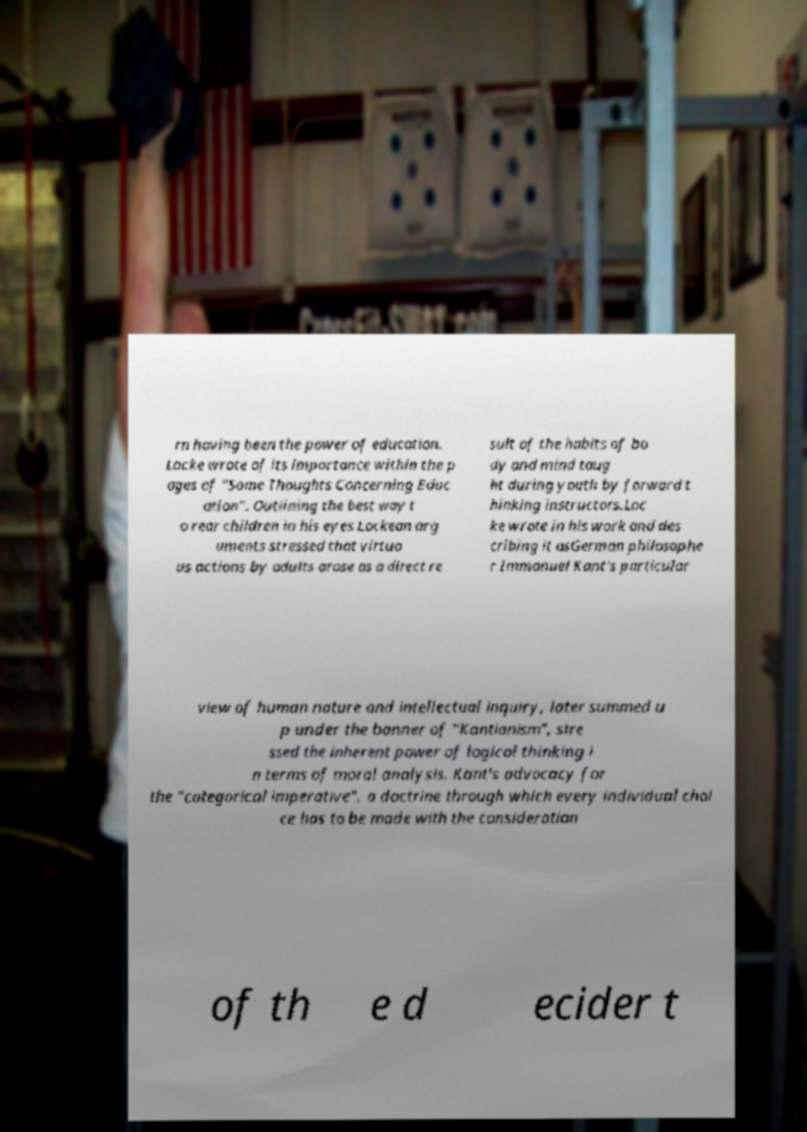For documentation purposes, I need the text within this image transcribed. Could you provide that? rn having been the power of education. Locke wrote of its importance within the p ages of "Some Thoughts Concerning Educ ation". Outlining the best way t o rear children in his eyes Lockean arg uments stressed that virtuo us actions by adults arose as a direct re sult of the habits of bo dy and mind taug ht during youth by forward t hinking instructors.Loc ke wrote in his work and des cribing it asGerman philosophe r Immanuel Kant's particular view of human nature and intellectual inquiry, later summed u p under the banner of "Kantianism", stre ssed the inherent power of logical thinking i n terms of moral analysis. Kant's advocacy for the "categorical imperative", a doctrine through which every individual choi ce has to be made with the consideration of th e d ecider t 